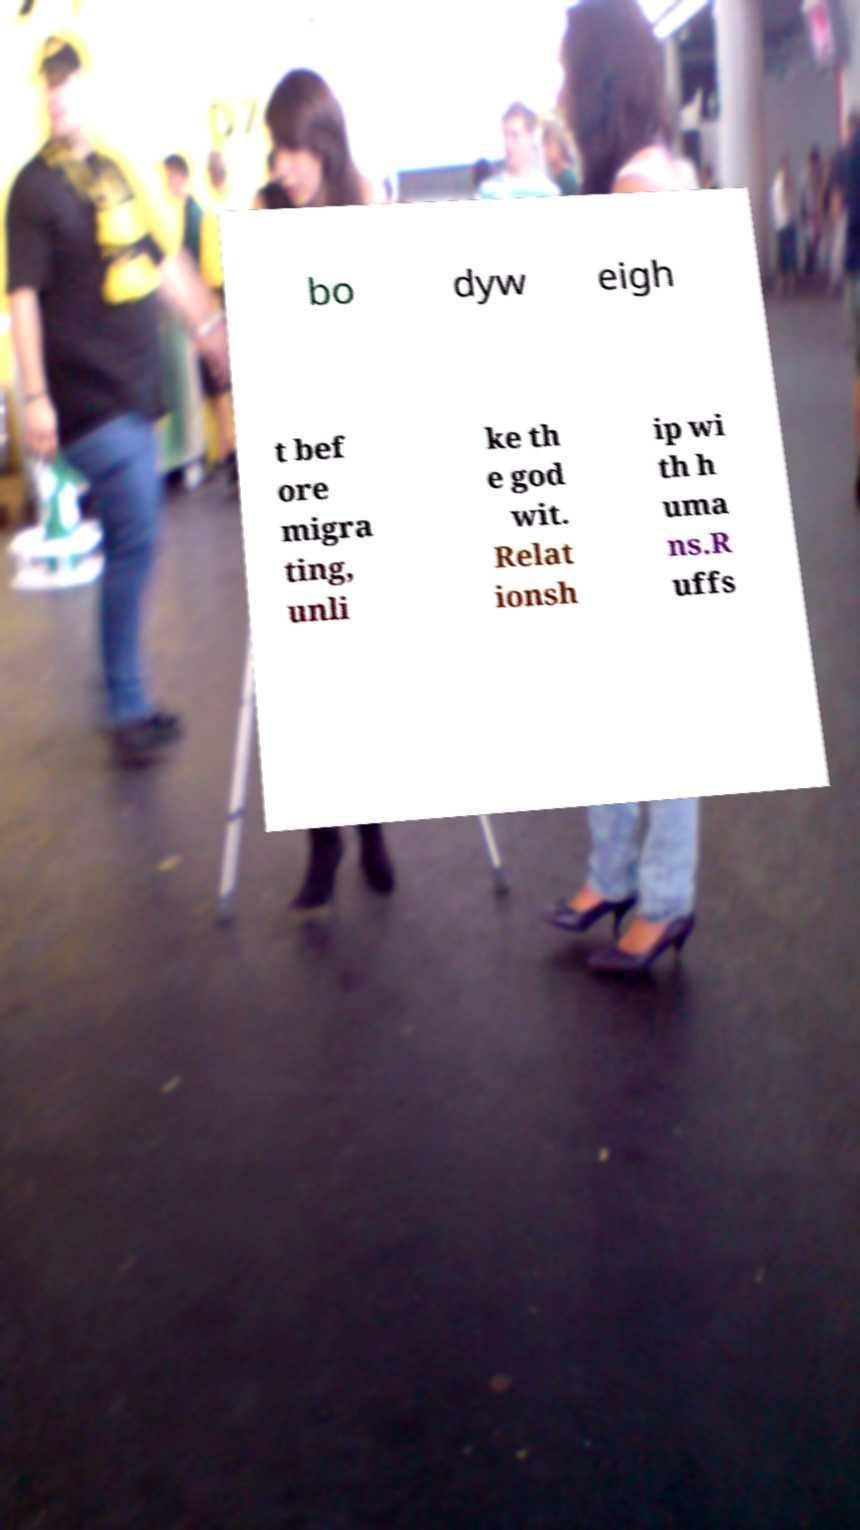Please read and relay the text visible in this image. What does it say? bo dyw eigh t bef ore migra ting, unli ke th e god wit. Relat ionsh ip wi th h uma ns.R uffs 